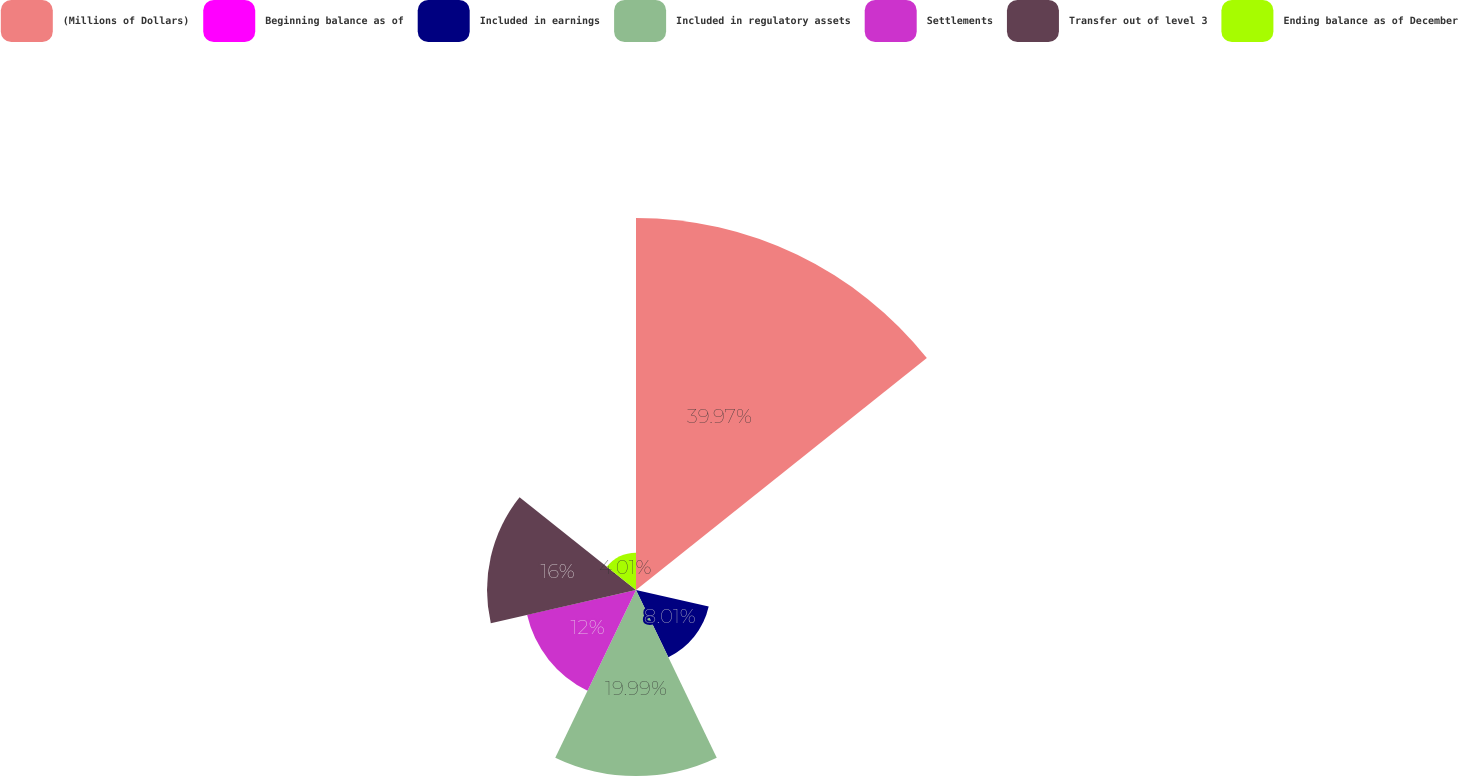Convert chart. <chart><loc_0><loc_0><loc_500><loc_500><pie_chart><fcel>(Millions of Dollars)<fcel>Beginning balance as of<fcel>Included in earnings<fcel>Included in regulatory assets<fcel>Settlements<fcel>Transfer out of level 3<fcel>Ending balance as of December<nl><fcel>39.96%<fcel>0.02%<fcel>8.01%<fcel>19.99%<fcel>12.0%<fcel>16.0%<fcel>4.01%<nl></chart> 